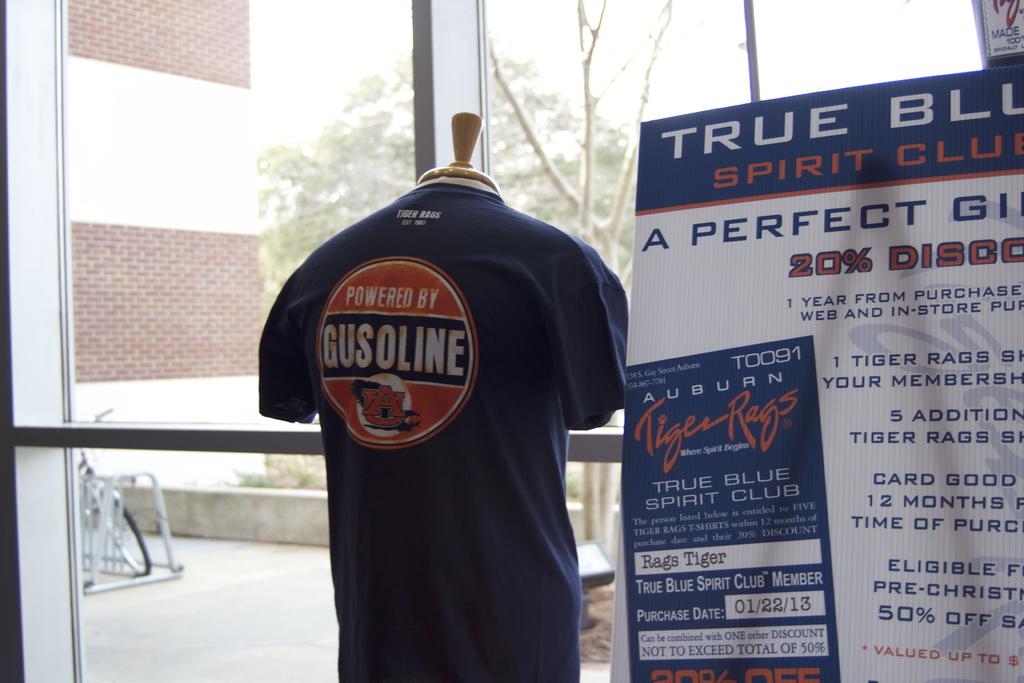What college is this shirt found in?
Your response must be concise. Auburn. 